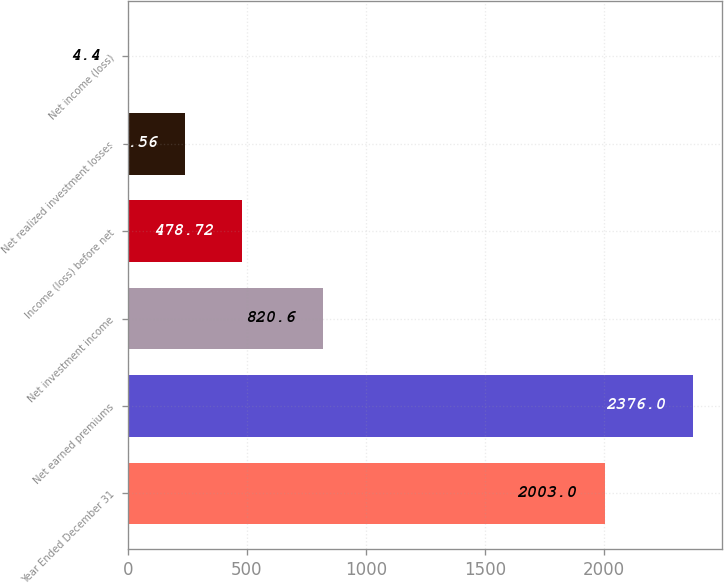<chart> <loc_0><loc_0><loc_500><loc_500><bar_chart><fcel>Year Ended December 31<fcel>Net earned premiums<fcel>Net investment income<fcel>Income (loss) before net<fcel>Net realized investment losses<fcel>Net income (loss)<nl><fcel>2003<fcel>2376<fcel>820.6<fcel>478.72<fcel>241.56<fcel>4.4<nl></chart> 